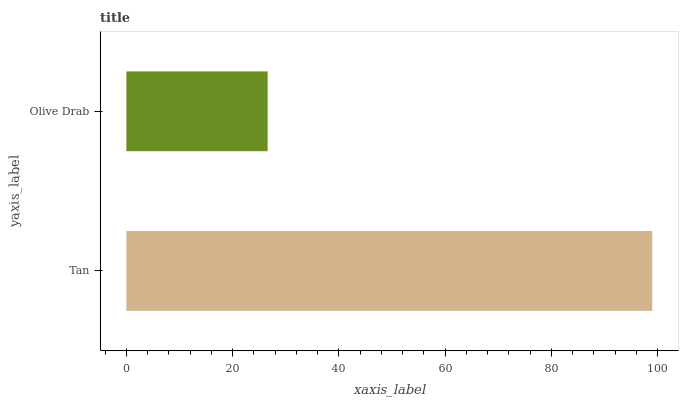Is Olive Drab the minimum?
Answer yes or no. Yes. Is Tan the maximum?
Answer yes or no. Yes. Is Olive Drab the maximum?
Answer yes or no. No. Is Tan greater than Olive Drab?
Answer yes or no. Yes. Is Olive Drab less than Tan?
Answer yes or no. Yes. Is Olive Drab greater than Tan?
Answer yes or no. No. Is Tan less than Olive Drab?
Answer yes or no. No. Is Tan the high median?
Answer yes or no. Yes. Is Olive Drab the low median?
Answer yes or no. Yes. Is Olive Drab the high median?
Answer yes or no. No. Is Tan the low median?
Answer yes or no. No. 